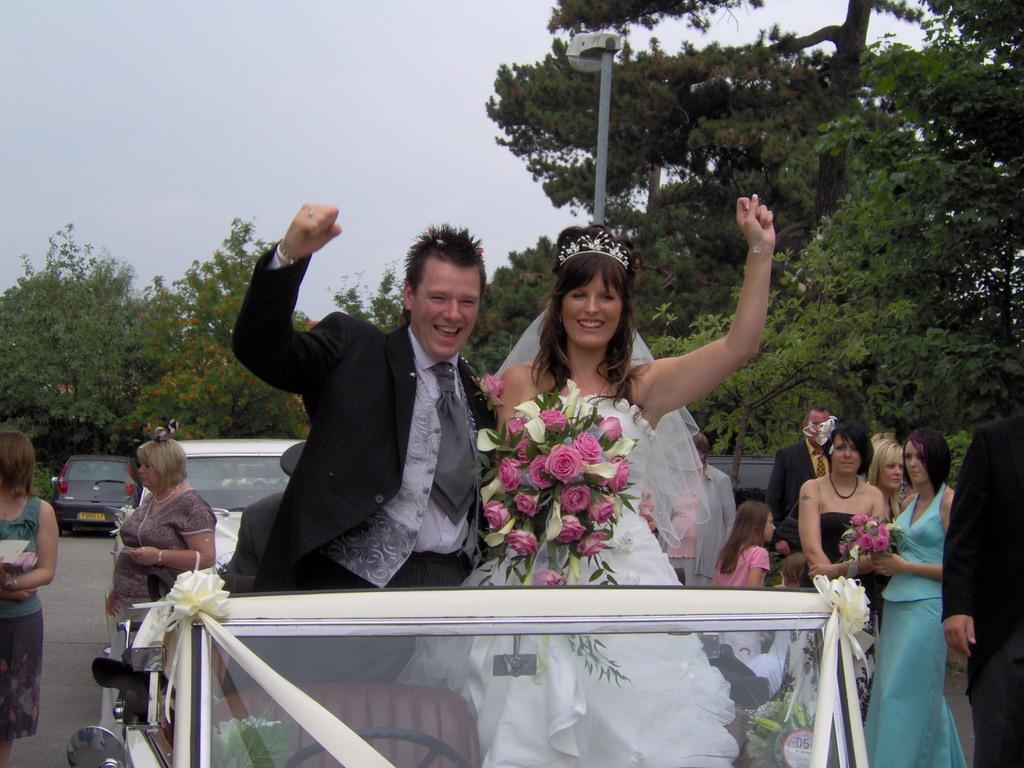How would you summarize this image in a sentence or two? This is the man standing in the car and smiling. This woman is holding a flower bouquet in her hand. There are few people standing in the road. These are the cars. This looks like a street light. I can see the trees with branches and leaves. 